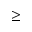<formula> <loc_0><loc_0><loc_500><loc_500>\geq</formula> 